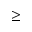<formula> <loc_0><loc_0><loc_500><loc_500>\geq</formula> 